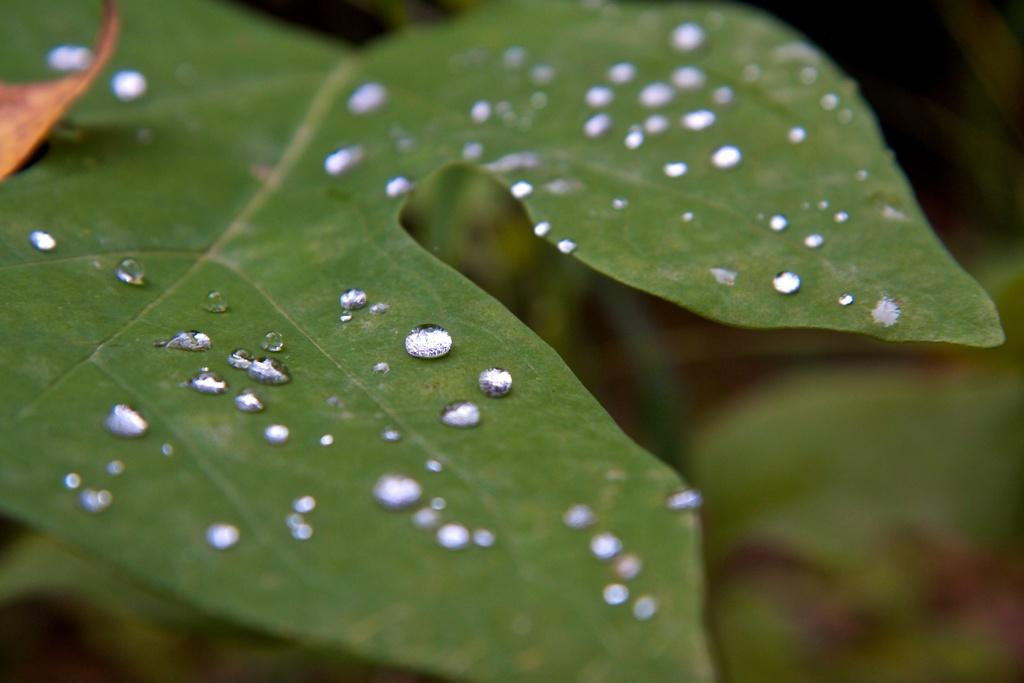What is present on the leaf in the image? There are water drops on a leaf in the image. How would you describe the overall appearance of the background in the image? The background of the image is blurry. What types of toys can be seen buried in the sand in the image? There is no sand or toys present in the image; it features water drops on a leaf with a blurry background. 